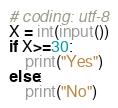Convert code to text. <code><loc_0><loc_0><loc_500><loc_500><_Python_># coding: utf-8
X = int(input())
if X>=30:
    print("Yes")
else:
    print("No")</code> 